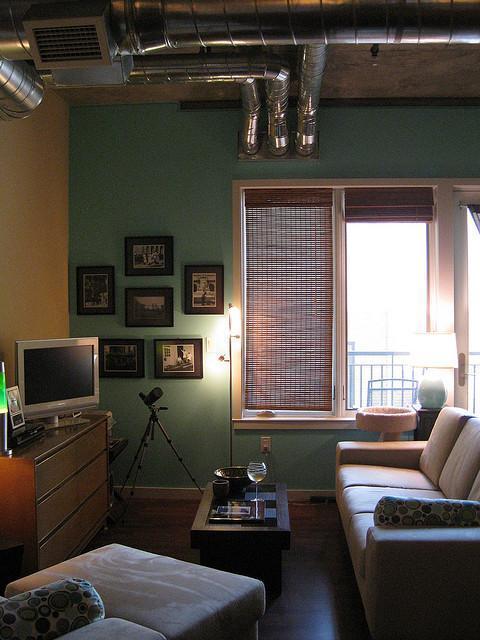How many photos are on the wall?
Give a very brief answer. 6. How many couches can you see?
Give a very brief answer. 2. 